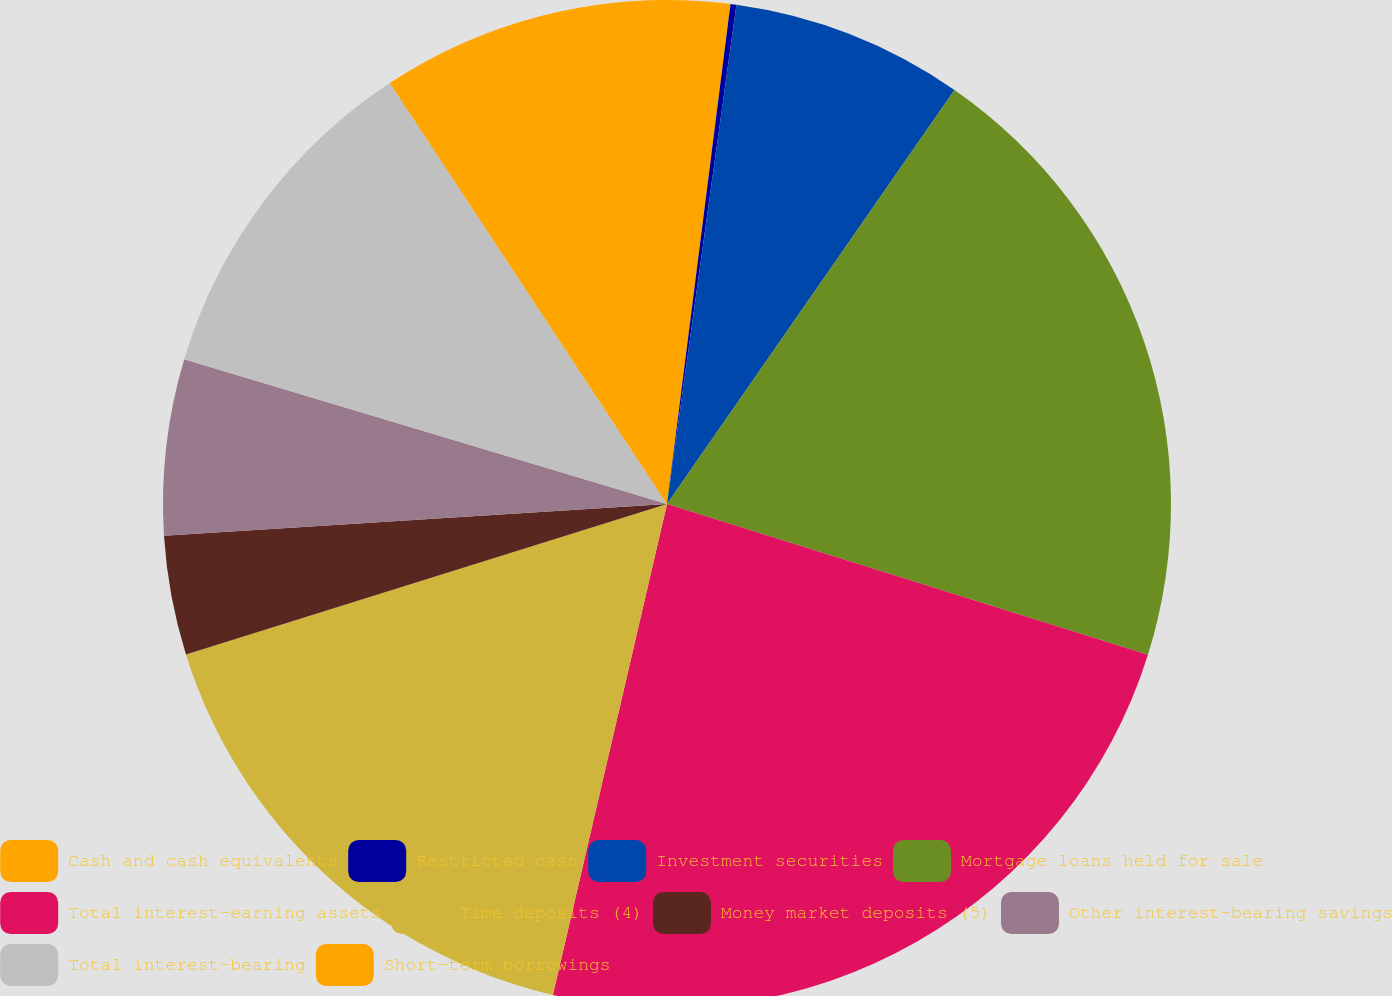Convert chart. <chart><loc_0><loc_0><loc_500><loc_500><pie_chart><fcel>Cash and cash equivalents<fcel>Restricted cash<fcel>Investment securities<fcel>Mortgage loans held for sale<fcel>Total interest-earning assets<fcel>Time deposits (4)<fcel>Money market deposits (5)<fcel>Other interest-bearing savings<fcel>Total interest-bearing<fcel>Short-term borrowings<nl><fcel>2.01%<fcel>0.19%<fcel>7.46%<fcel>20.17%<fcel>23.8%<fcel>16.54%<fcel>3.82%<fcel>5.64%<fcel>11.09%<fcel>9.27%<nl></chart> 